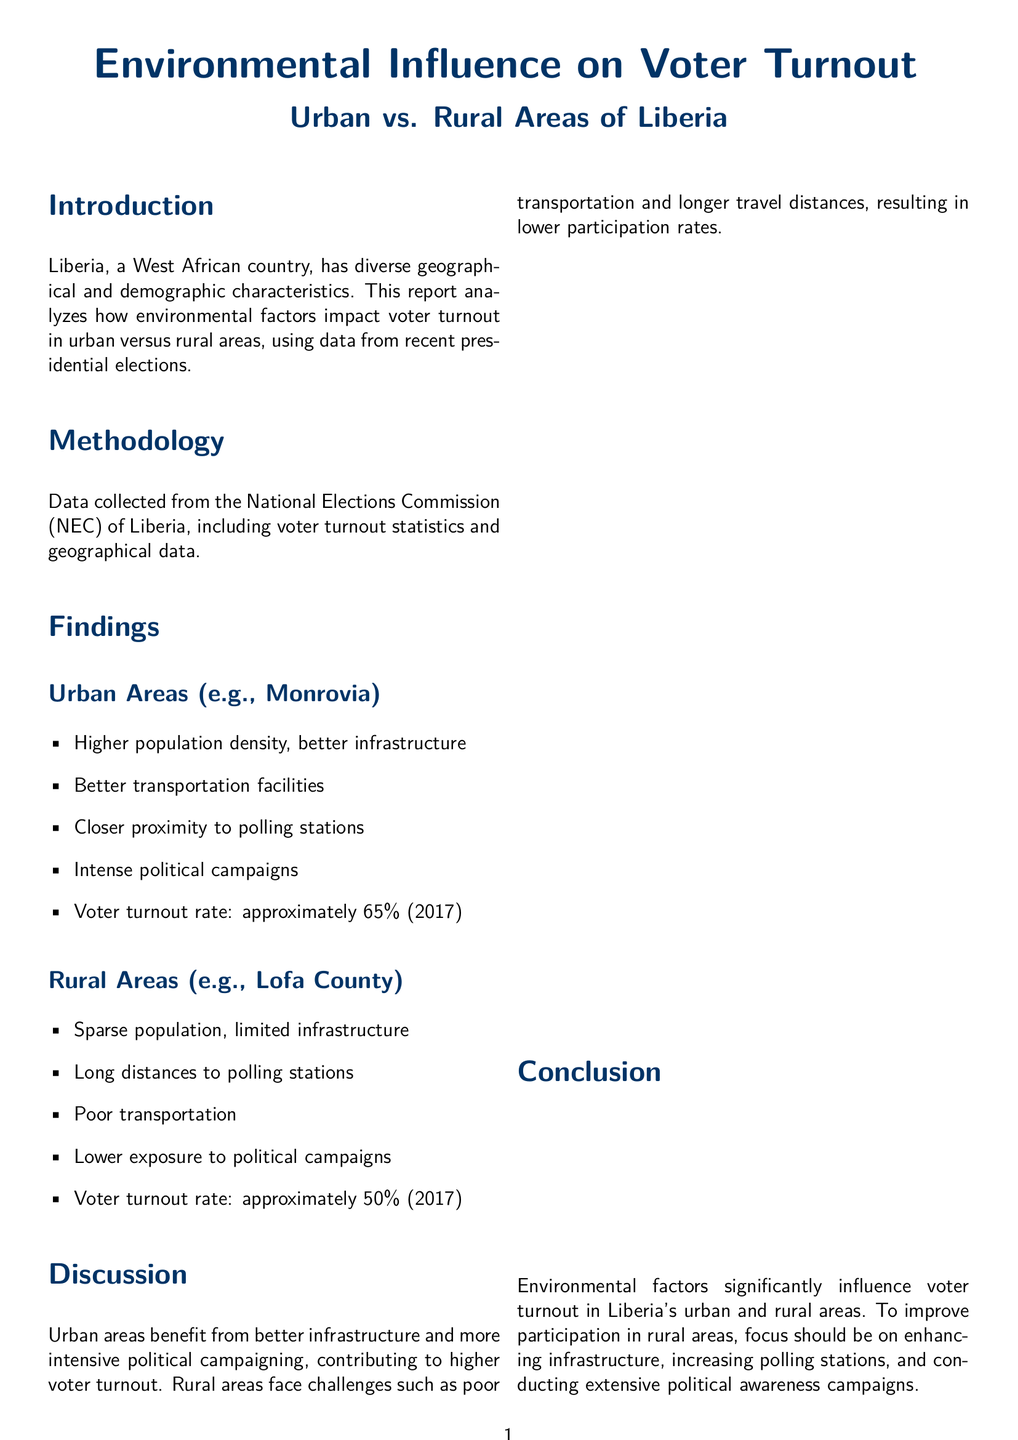What is the voter turnout rate in Monrovia? The voter turnout rate in Monrovia is specified in the findings section of the document as approximately 65% (2017).
Answer: 65% What are the key factors affecting voter turnout? The document lists several factors affecting voter turnout, including transportation infrastructure, distance to polling stations, and others in the key factors section.
Answer: Transportation infrastructure, distance to polling stations, political campaign intensity, population density, access to public services What is the voter turnout rate in Lofa County? The findings section explicitly states the voter turnout rate in Lofa County as approximately 50% (2017).
Answer: 50% Which area has better transportation facilities? The findings for urban areas indicate they have better transportation facilities compared to rural areas, as specified in the report.
Answer: Urban Areas What does the report recommend for rural areas? The recommendations section outlines several improvements for rural areas, focusing on enhancing infrastructure, increasing polling stations, and more.
Answer: Improve rural infrastructure How does population density affect voter turnout? The discussion suggests that higher population density in urban areas contributes to higher voter turnout due to better accessibility and political campaigning.
Answer: Higher voter turnout What is the main conclusion of the report? The conclusion summarizes the findings on how environmental factors significantly influence voter turnout differently in urban and rural areas.
Answer: Environmental factors significantly influence voter turnout How was the data for the report collected? The methodology section indicates that the data was collected from the National Elections Commission (NEC) of Liberia.
Answer: National Elections Commission (NEC) What is the title of the report? The title is presented at the beginning of the document, emphasizing its focus on environmental influence on voter turnout in Liberia.
Answer: Environmental Influence on Voter Turnout 